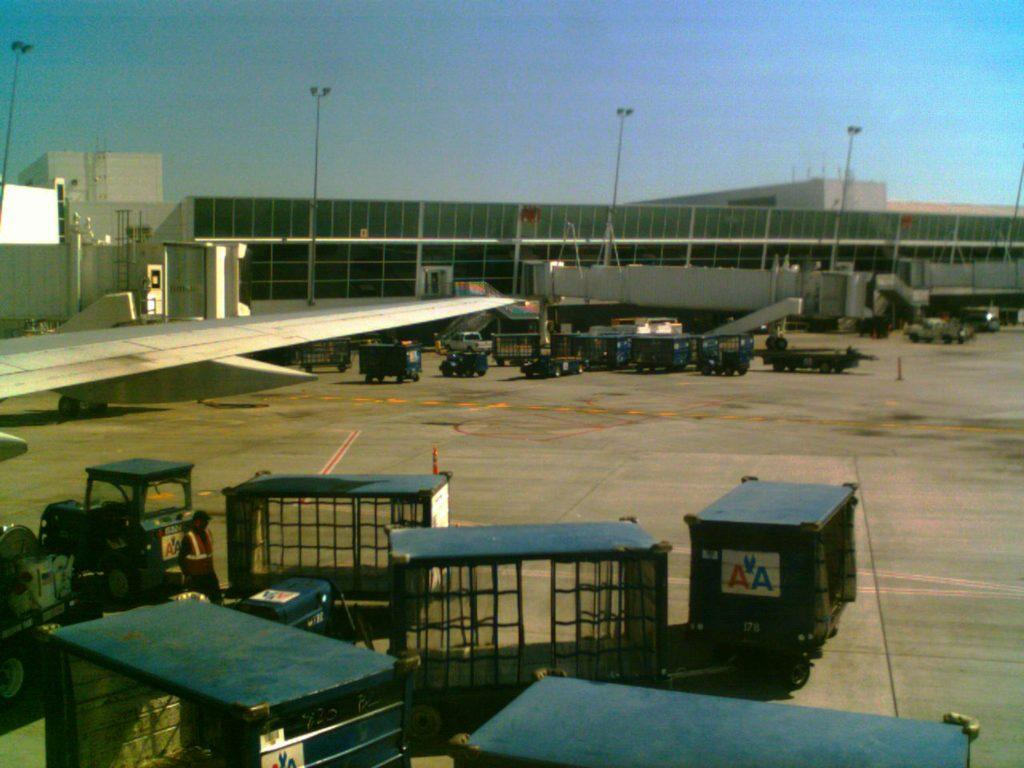<image>
Summarize the visual content of the image. Vehicle outside of an airport that says AA on it. 